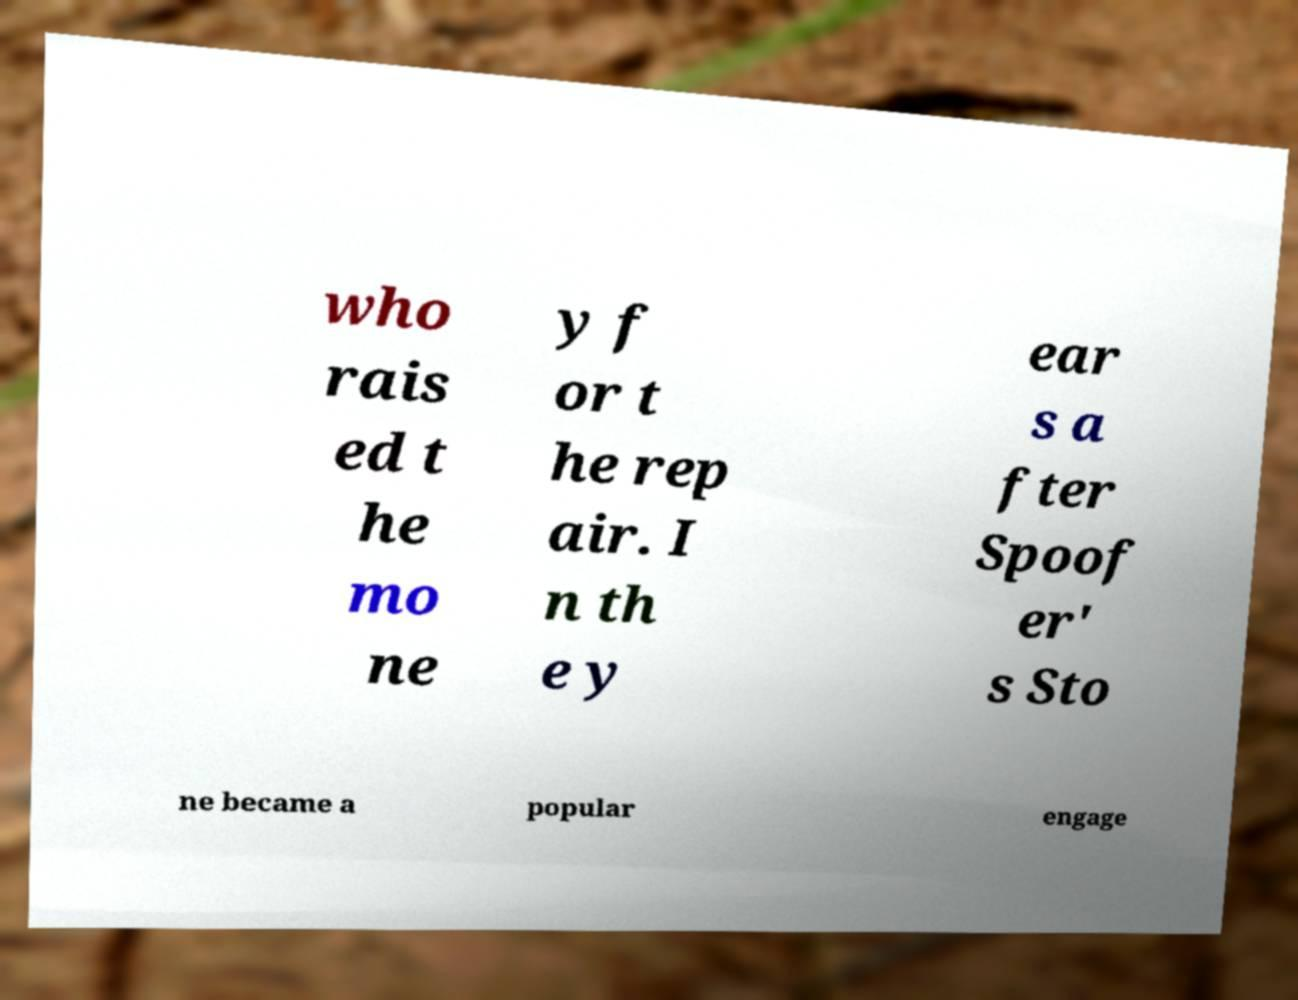Could you extract and type out the text from this image? who rais ed t he mo ne y f or t he rep air. I n th e y ear s a fter Spoof er' s Sto ne became a popular engage 